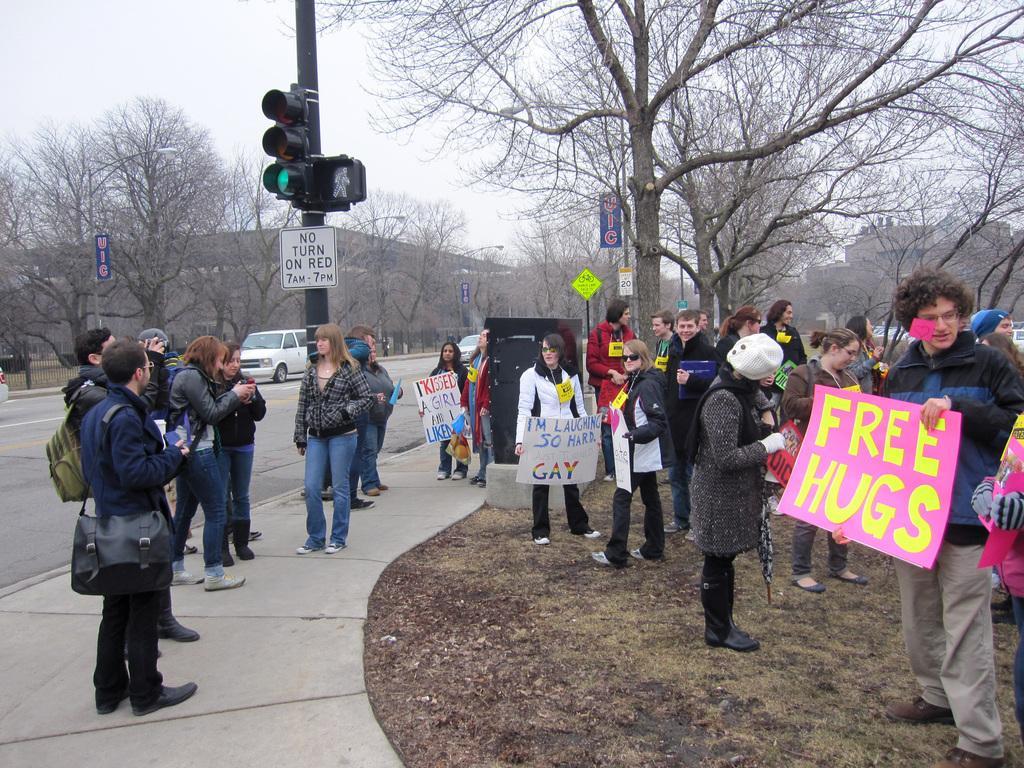Describe this image in one or two sentences. In the image we can see there are people standing on the ground and there are few people holding placards in their hands. There its written ¨Free Hugs¨ on a placard and there is a traffic signal pole kept on the footpath. Behind there are trees and there is a building. There are cars parked on the road and the sky is clear. 